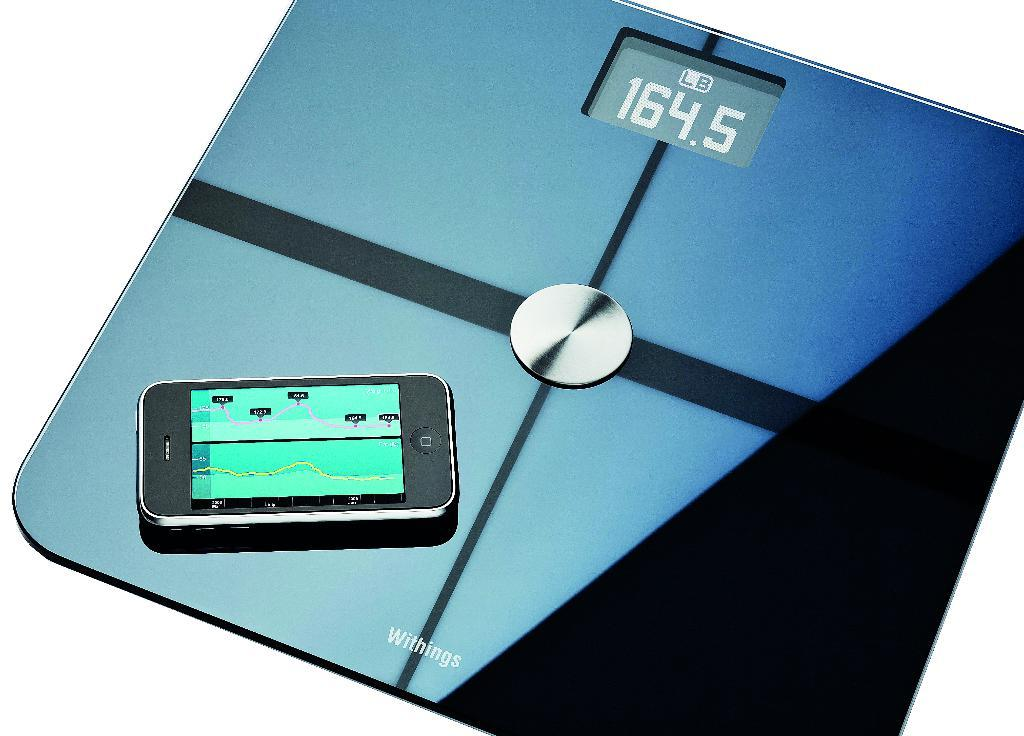<image>
Render a clear and concise summary of the photo. A scale that reads 164.5 and has a phone on it open to a tracking sort of app. 